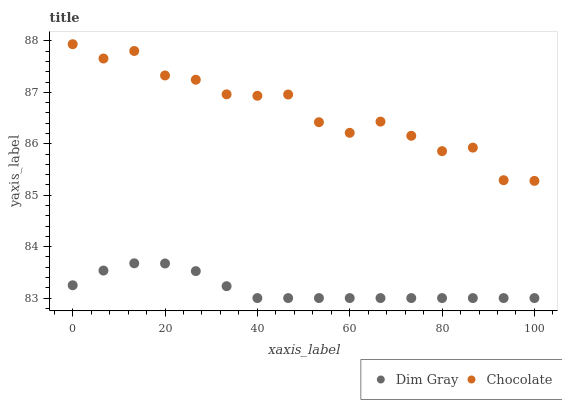Does Dim Gray have the minimum area under the curve?
Answer yes or no. Yes. Does Chocolate have the maximum area under the curve?
Answer yes or no. Yes. Does Chocolate have the minimum area under the curve?
Answer yes or no. No. Is Dim Gray the smoothest?
Answer yes or no. Yes. Is Chocolate the roughest?
Answer yes or no. Yes. Is Chocolate the smoothest?
Answer yes or no. No. Does Dim Gray have the lowest value?
Answer yes or no. Yes. Does Chocolate have the lowest value?
Answer yes or no. No. Does Chocolate have the highest value?
Answer yes or no. Yes. Is Dim Gray less than Chocolate?
Answer yes or no. Yes. Is Chocolate greater than Dim Gray?
Answer yes or no. Yes. Does Dim Gray intersect Chocolate?
Answer yes or no. No. 